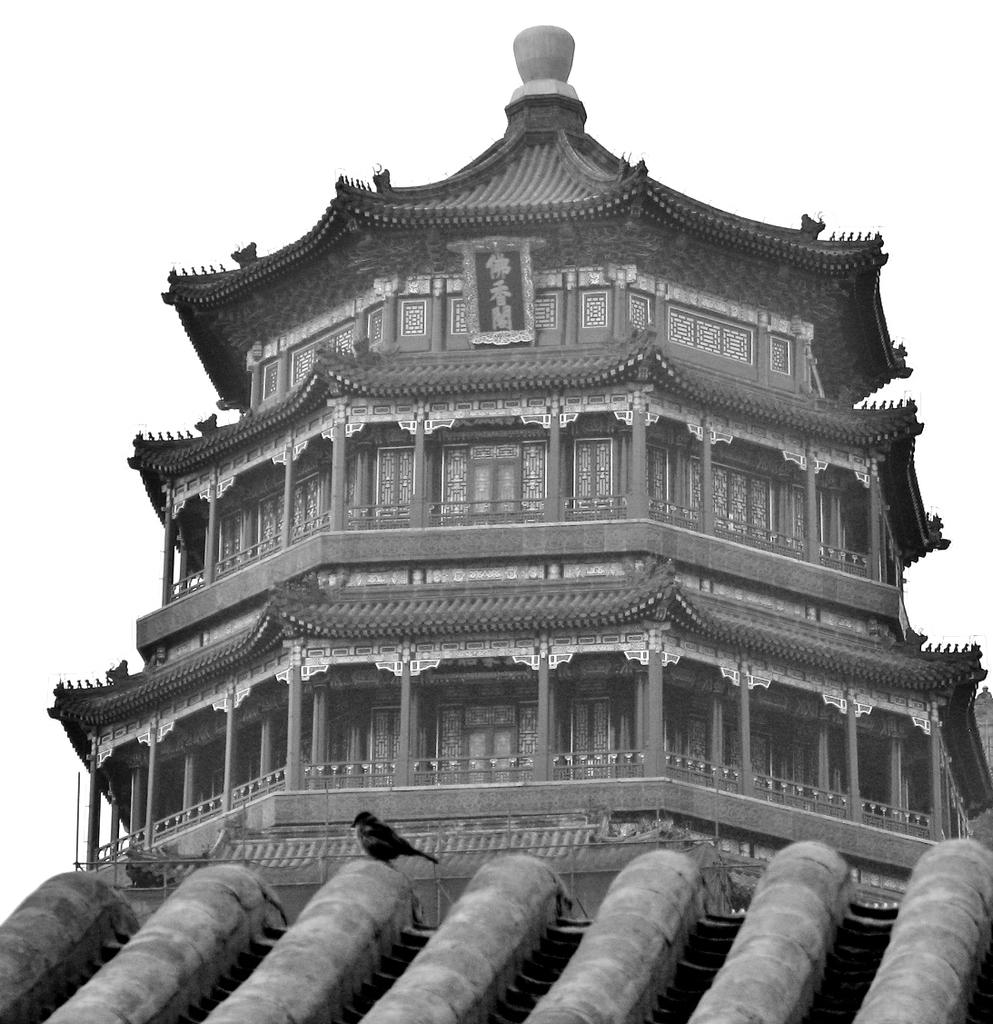What is the color scheme of the image? The image is black and white. What type of structure can be seen in the image? There is a building in the image. What architectural feature is present in the image? There are pillars in the image. What can be seen in the background of the image? The sky is visible in the background of the image. What type of coat is the building wearing in the image? Buildings do not wear coats, so this question is not applicable to the image. 